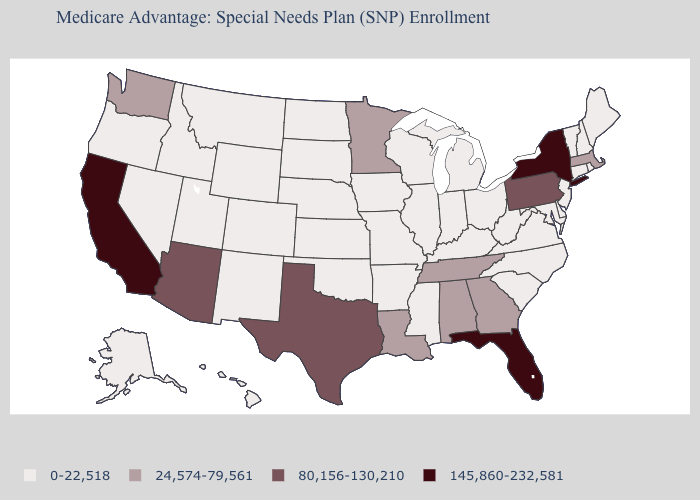What is the value of Montana?
Short answer required. 0-22,518. What is the highest value in states that border Washington?
Write a very short answer. 0-22,518. How many symbols are there in the legend?
Short answer required. 4. What is the value of Missouri?
Short answer required. 0-22,518. What is the value of Nebraska?
Write a very short answer. 0-22,518. Among the states that border South Dakota , which have the highest value?
Short answer required. Minnesota. What is the value of Arkansas?
Keep it brief. 0-22,518. What is the lowest value in states that border Vermont?
Answer briefly. 0-22,518. Name the states that have a value in the range 24,574-79,561?
Answer briefly. Alabama, Georgia, Louisiana, Massachusetts, Minnesota, Tennessee, Washington. What is the value of West Virginia?
Short answer required. 0-22,518. What is the lowest value in the Northeast?
Write a very short answer. 0-22,518. Does South Carolina have a lower value than Massachusetts?
Be succinct. Yes. Among the states that border Missouri , which have the highest value?
Quick response, please. Tennessee. Which states have the lowest value in the West?
Write a very short answer. Alaska, Colorado, Hawaii, Idaho, Montana, New Mexico, Nevada, Oregon, Utah, Wyoming. Which states have the lowest value in the South?
Write a very short answer. Arkansas, Delaware, Kentucky, Maryland, Mississippi, North Carolina, Oklahoma, South Carolina, Virginia, West Virginia. 